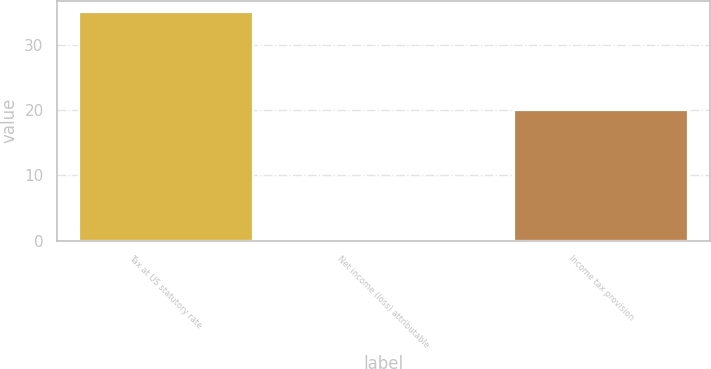<chart> <loc_0><loc_0><loc_500><loc_500><bar_chart><fcel>Tax at US statutory rate<fcel>Net income (loss) attributable<fcel>Income tax provision<nl><fcel>35<fcel>0.1<fcel>20<nl></chart> 